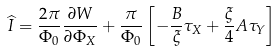<formula> <loc_0><loc_0><loc_500><loc_500>\widehat { I } = \frac { 2 \pi } { \Phi _ { 0 } } \frac { \partial W } { \partial \Phi _ { X } } + \frac { \pi } { \Phi _ { 0 } } \left [ - \frac { B } { \xi } \tau _ { X } + \frac { \xi } { 4 } A \tau _ { Y } \right ]</formula> 